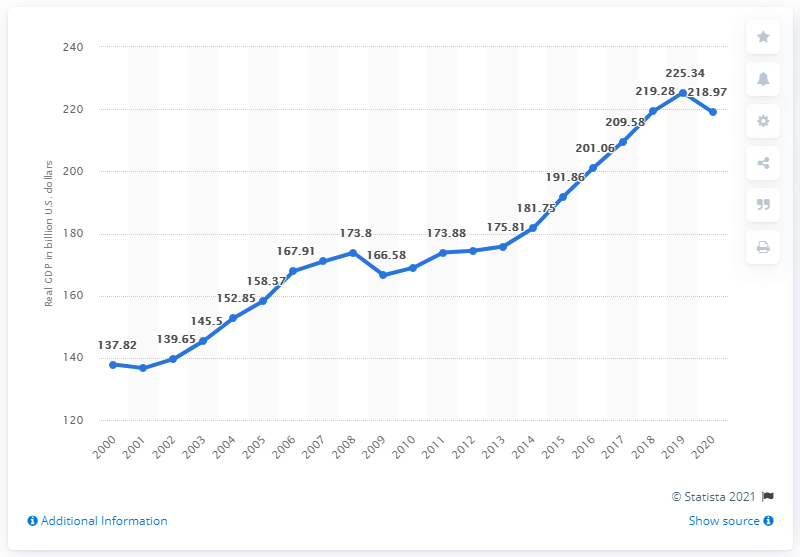Outline some significant characteristics in this image. Oregon's Gross Domestic Product (GDP) in 2020 was 218.97. The real GDP of Oregon in dollars was 225.34. 